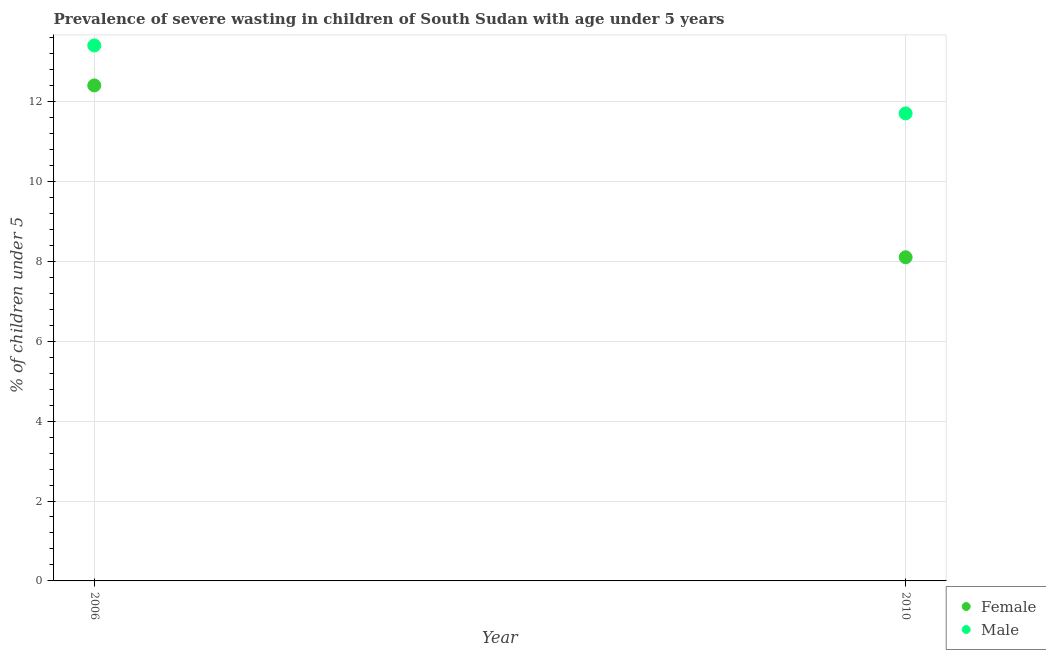How many different coloured dotlines are there?
Your answer should be compact. 2. What is the percentage of undernourished female children in 2006?
Offer a very short reply. 12.4. Across all years, what is the maximum percentage of undernourished female children?
Provide a short and direct response. 12.4. Across all years, what is the minimum percentage of undernourished male children?
Give a very brief answer. 11.7. In which year was the percentage of undernourished female children maximum?
Your answer should be very brief. 2006. What is the total percentage of undernourished female children in the graph?
Offer a terse response. 20.5. What is the difference between the percentage of undernourished female children in 2006 and that in 2010?
Give a very brief answer. 4.3. What is the difference between the percentage of undernourished male children in 2010 and the percentage of undernourished female children in 2006?
Offer a terse response. -0.7. What is the average percentage of undernourished female children per year?
Your answer should be compact. 10.25. In the year 2010, what is the difference between the percentage of undernourished female children and percentage of undernourished male children?
Keep it short and to the point. -3.6. In how many years, is the percentage of undernourished male children greater than 9.6 %?
Make the answer very short. 2. What is the ratio of the percentage of undernourished male children in 2006 to that in 2010?
Keep it short and to the point. 1.15. Does the percentage of undernourished female children monotonically increase over the years?
Provide a short and direct response. No. Is the percentage of undernourished female children strictly greater than the percentage of undernourished male children over the years?
Offer a very short reply. No. Is the percentage of undernourished male children strictly less than the percentage of undernourished female children over the years?
Provide a succinct answer. No. How many dotlines are there?
Provide a short and direct response. 2. How many years are there in the graph?
Keep it short and to the point. 2. Are the values on the major ticks of Y-axis written in scientific E-notation?
Keep it short and to the point. No. Does the graph contain any zero values?
Your response must be concise. No. How are the legend labels stacked?
Ensure brevity in your answer.  Vertical. What is the title of the graph?
Make the answer very short. Prevalence of severe wasting in children of South Sudan with age under 5 years. Does "Sanitation services" appear as one of the legend labels in the graph?
Give a very brief answer. No. What is the label or title of the X-axis?
Provide a short and direct response. Year. What is the label or title of the Y-axis?
Your response must be concise.  % of children under 5. What is the  % of children under 5 of Female in 2006?
Your answer should be compact. 12.4. What is the  % of children under 5 of Male in 2006?
Give a very brief answer. 13.4. What is the  % of children under 5 in Female in 2010?
Your answer should be very brief. 8.1. What is the  % of children under 5 in Male in 2010?
Offer a terse response. 11.7. Across all years, what is the maximum  % of children under 5 of Female?
Provide a succinct answer. 12.4. Across all years, what is the maximum  % of children under 5 in Male?
Provide a succinct answer. 13.4. Across all years, what is the minimum  % of children under 5 of Female?
Keep it short and to the point. 8.1. Across all years, what is the minimum  % of children under 5 of Male?
Your response must be concise. 11.7. What is the total  % of children under 5 in Female in the graph?
Give a very brief answer. 20.5. What is the total  % of children under 5 of Male in the graph?
Make the answer very short. 25.1. What is the difference between the  % of children under 5 of Male in 2006 and that in 2010?
Provide a succinct answer. 1.7. What is the average  % of children under 5 in Female per year?
Provide a succinct answer. 10.25. What is the average  % of children under 5 in Male per year?
Your response must be concise. 12.55. In the year 2006, what is the difference between the  % of children under 5 of Female and  % of children under 5 of Male?
Give a very brief answer. -1. What is the ratio of the  % of children under 5 in Female in 2006 to that in 2010?
Give a very brief answer. 1.53. What is the ratio of the  % of children under 5 in Male in 2006 to that in 2010?
Ensure brevity in your answer.  1.15. What is the difference between the highest and the second highest  % of children under 5 of Female?
Ensure brevity in your answer.  4.3. What is the difference between the highest and the second highest  % of children under 5 of Male?
Provide a short and direct response. 1.7. What is the difference between the highest and the lowest  % of children under 5 in Female?
Offer a terse response. 4.3. What is the difference between the highest and the lowest  % of children under 5 in Male?
Ensure brevity in your answer.  1.7. 